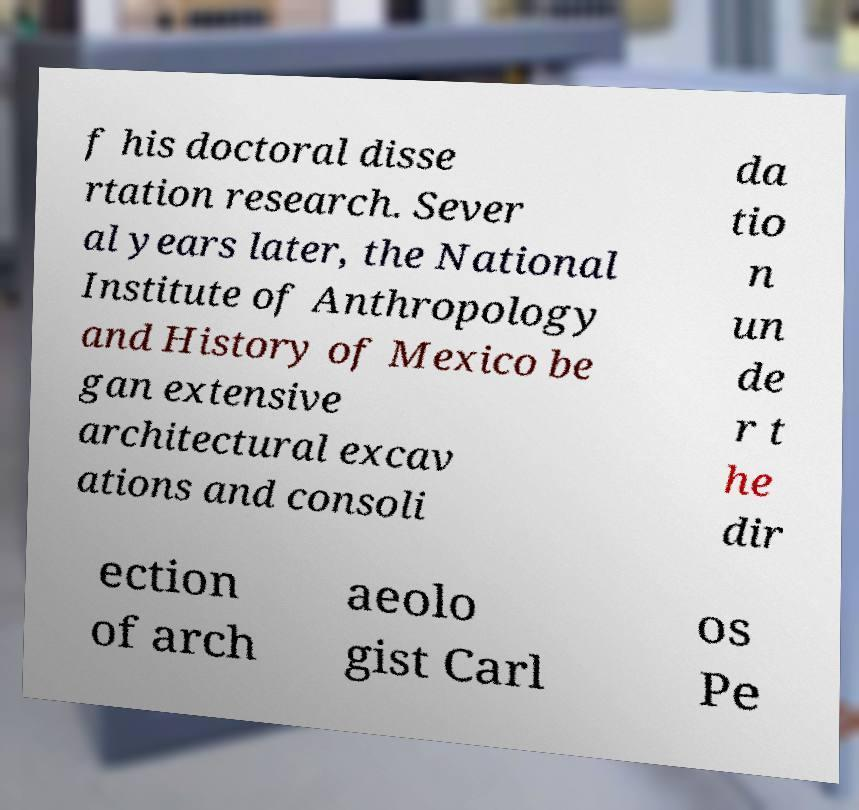Could you extract and type out the text from this image? f his doctoral disse rtation research. Sever al years later, the National Institute of Anthropology and History of Mexico be gan extensive architectural excav ations and consoli da tio n un de r t he dir ection of arch aeolo gist Carl os Pe 